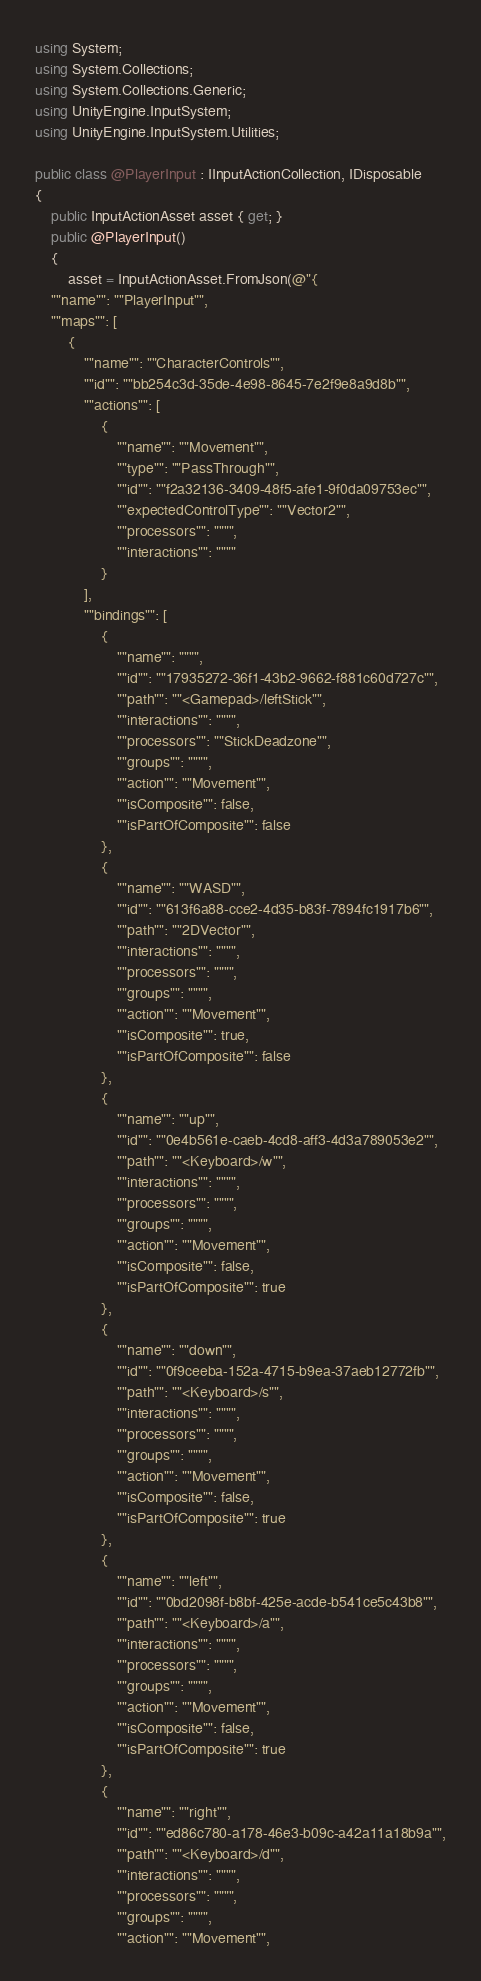<code> <loc_0><loc_0><loc_500><loc_500><_C#_>using System;
using System.Collections;
using System.Collections.Generic;
using UnityEngine.InputSystem;
using UnityEngine.InputSystem.Utilities;

public class @PlayerInput : IInputActionCollection, IDisposable
{
    public InputActionAsset asset { get; }
    public @PlayerInput()
    {
        asset = InputActionAsset.FromJson(@"{
    ""name"": ""PlayerInput"",
    ""maps"": [
        {
            ""name"": ""CharacterControls"",
            ""id"": ""bb254c3d-35de-4e98-8645-7e2f9e8a9d8b"",
            ""actions"": [
                {
                    ""name"": ""Movement"",
                    ""type"": ""PassThrough"",
                    ""id"": ""f2a32136-3409-48f5-afe1-9f0da09753ec"",
                    ""expectedControlType"": ""Vector2"",
                    ""processors"": """",
                    ""interactions"": """"
                }
            ],
            ""bindings"": [
                {
                    ""name"": """",
                    ""id"": ""17935272-36f1-43b2-9662-f881c60d727c"",
                    ""path"": ""<Gamepad>/leftStick"",
                    ""interactions"": """",
                    ""processors"": ""StickDeadzone"",
                    ""groups"": """",
                    ""action"": ""Movement"",
                    ""isComposite"": false,
                    ""isPartOfComposite"": false
                },
                {
                    ""name"": ""WASD"",
                    ""id"": ""613f6a88-cce2-4d35-b83f-7894fc1917b6"",
                    ""path"": ""2DVector"",
                    ""interactions"": """",
                    ""processors"": """",
                    ""groups"": """",
                    ""action"": ""Movement"",
                    ""isComposite"": true,
                    ""isPartOfComposite"": false
                },
                {
                    ""name"": ""up"",
                    ""id"": ""0e4b561e-caeb-4cd8-aff3-4d3a789053e2"",
                    ""path"": ""<Keyboard>/w"",
                    ""interactions"": """",
                    ""processors"": """",
                    ""groups"": """",
                    ""action"": ""Movement"",
                    ""isComposite"": false,
                    ""isPartOfComposite"": true
                },
                {
                    ""name"": ""down"",
                    ""id"": ""0f9ceeba-152a-4715-b9ea-37aeb12772fb"",
                    ""path"": ""<Keyboard>/s"",
                    ""interactions"": """",
                    ""processors"": """",
                    ""groups"": """",
                    ""action"": ""Movement"",
                    ""isComposite"": false,
                    ""isPartOfComposite"": true
                },
                {
                    ""name"": ""left"",
                    ""id"": ""0bd2098f-b8bf-425e-acde-b541ce5c43b8"",
                    ""path"": ""<Keyboard>/a"",
                    ""interactions"": """",
                    ""processors"": """",
                    ""groups"": """",
                    ""action"": ""Movement"",
                    ""isComposite"": false,
                    ""isPartOfComposite"": true
                },
                {
                    ""name"": ""right"",
                    ""id"": ""ed86c780-a178-46e3-b09c-a42a11a18b9a"",
                    ""path"": ""<Keyboard>/d"",
                    ""interactions"": """",
                    ""processors"": """",
                    ""groups"": """",
                    ""action"": ""Movement"",</code> 